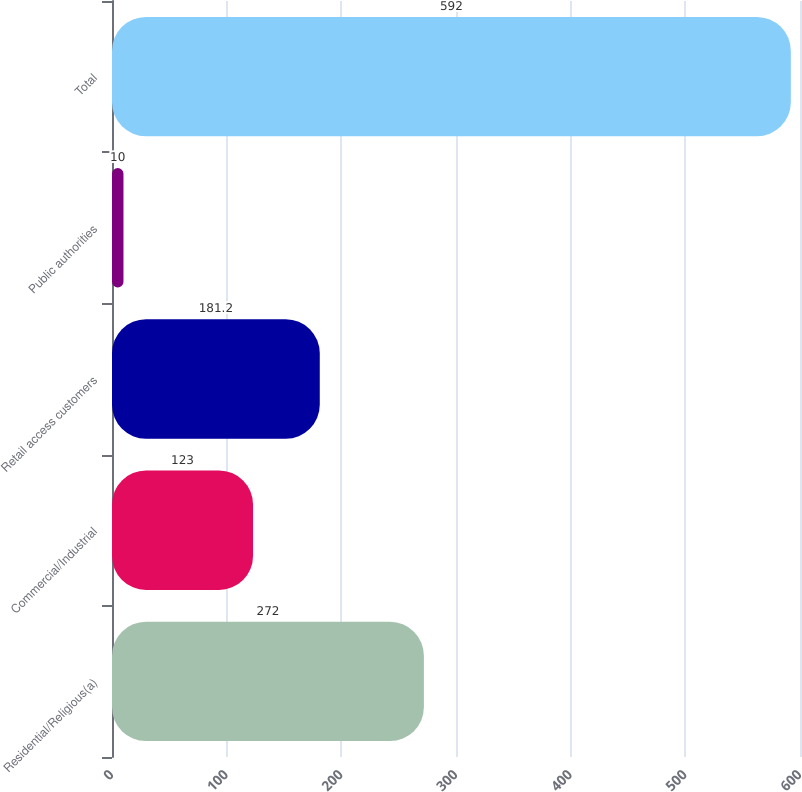Convert chart to OTSL. <chart><loc_0><loc_0><loc_500><loc_500><bar_chart><fcel>Residential/Religious(a)<fcel>Commercial/Industrial<fcel>Retail access customers<fcel>Public authorities<fcel>Total<nl><fcel>272<fcel>123<fcel>181.2<fcel>10<fcel>592<nl></chart> 